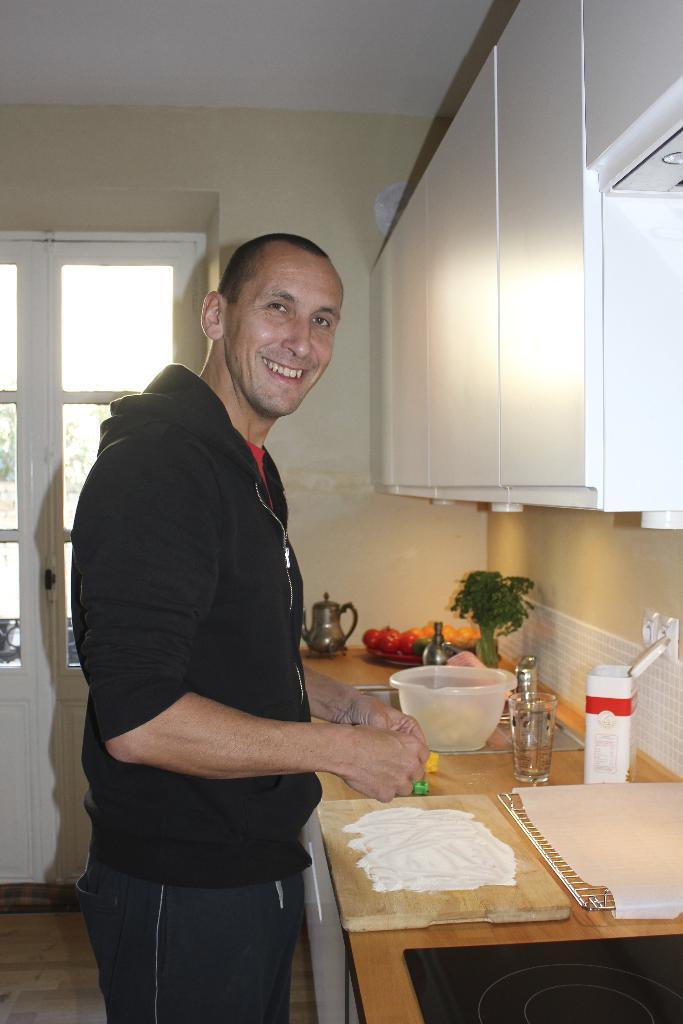What is the man in the image doing? The man is doing something on a chopping pad in the image. What is the man standing near in the image? There is a table in the image, and the man is standing near it. What type of glass is present on the table? A ball jar glass is present on the table in the image. What else can be seen on the table besides the ball jar glass? There are other unspecified items on the table in the image. How many fish are swimming in the ball jar glass in the image? There are no fish present in the image, and the ball jar glass is not filled with water. 